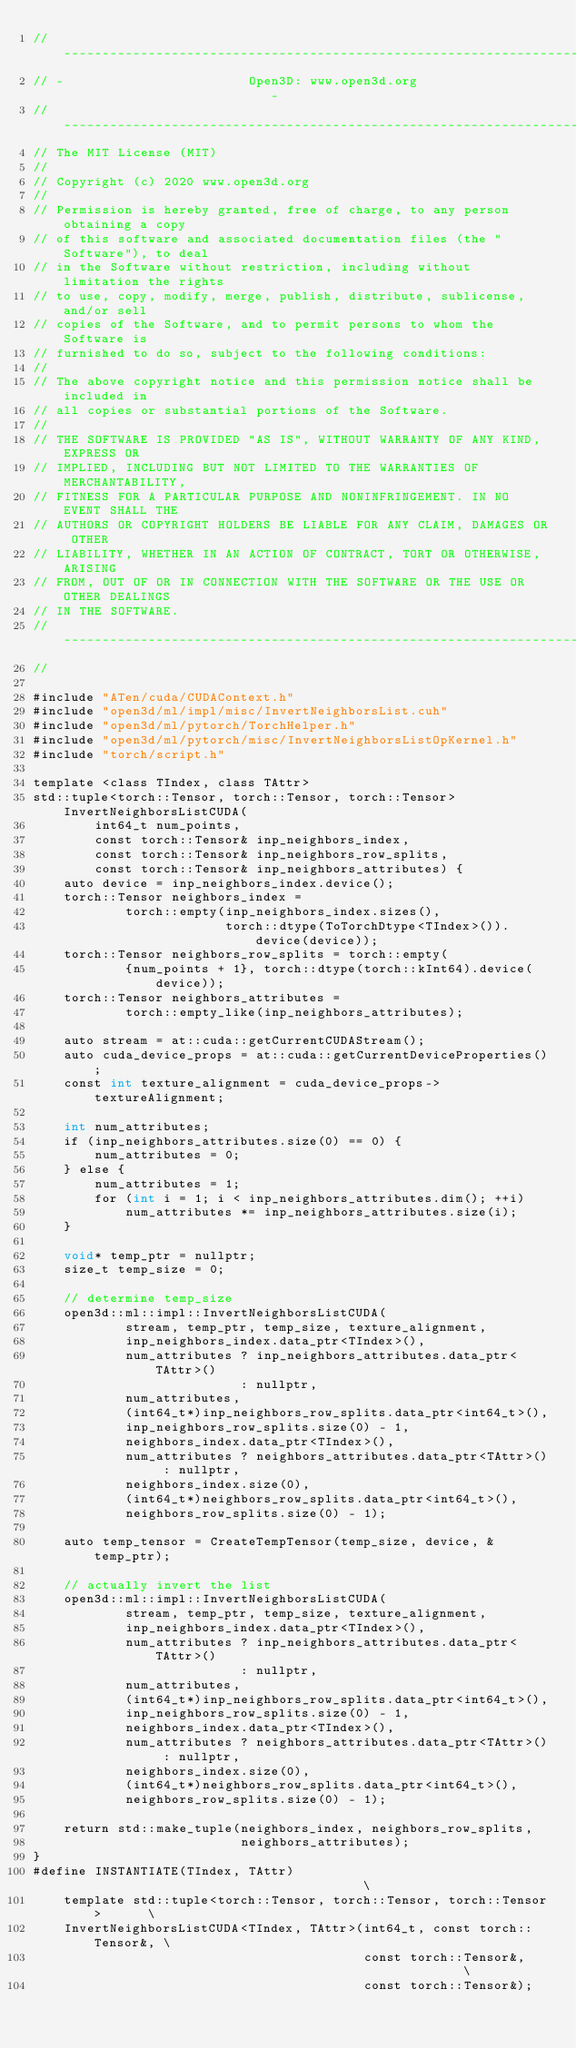Convert code to text. <code><loc_0><loc_0><loc_500><loc_500><_Cuda_>// ----------------------------------------------------------------------------
// -                        Open3D: www.open3d.org                            -
// ----------------------------------------------------------------------------
// The MIT License (MIT)
//
// Copyright (c) 2020 www.open3d.org
//
// Permission is hereby granted, free of charge, to any person obtaining a copy
// of this software and associated documentation files (the "Software"), to deal
// in the Software without restriction, including without limitation the rights
// to use, copy, modify, merge, publish, distribute, sublicense, and/or sell
// copies of the Software, and to permit persons to whom the Software is
// furnished to do so, subject to the following conditions:
//
// The above copyright notice and this permission notice shall be included in
// all copies or substantial portions of the Software.
//
// THE SOFTWARE IS PROVIDED "AS IS", WITHOUT WARRANTY OF ANY KIND, EXPRESS OR
// IMPLIED, INCLUDING BUT NOT LIMITED TO THE WARRANTIES OF MERCHANTABILITY,
// FITNESS FOR A PARTICULAR PURPOSE AND NONINFRINGEMENT. IN NO EVENT SHALL THE
// AUTHORS OR COPYRIGHT HOLDERS BE LIABLE FOR ANY CLAIM, DAMAGES OR OTHER
// LIABILITY, WHETHER IN AN ACTION OF CONTRACT, TORT OR OTHERWISE, ARISING
// FROM, OUT OF OR IN CONNECTION WITH THE SOFTWARE OR THE USE OR OTHER DEALINGS
// IN THE SOFTWARE.
// ----------------------------------------------------------------------------
//

#include "ATen/cuda/CUDAContext.h"
#include "open3d/ml/impl/misc/InvertNeighborsList.cuh"
#include "open3d/ml/pytorch/TorchHelper.h"
#include "open3d/ml/pytorch/misc/InvertNeighborsListOpKernel.h"
#include "torch/script.h"

template <class TIndex, class TAttr>
std::tuple<torch::Tensor, torch::Tensor, torch::Tensor> InvertNeighborsListCUDA(
        int64_t num_points,
        const torch::Tensor& inp_neighbors_index,
        const torch::Tensor& inp_neighbors_row_splits,
        const torch::Tensor& inp_neighbors_attributes) {
    auto device = inp_neighbors_index.device();
    torch::Tensor neighbors_index =
            torch::empty(inp_neighbors_index.sizes(),
                         torch::dtype(ToTorchDtype<TIndex>()).device(device));
    torch::Tensor neighbors_row_splits = torch::empty(
            {num_points + 1}, torch::dtype(torch::kInt64).device(device));
    torch::Tensor neighbors_attributes =
            torch::empty_like(inp_neighbors_attributes);

    auto stream = at::cuda::getCurrentCUDAStream();
    auto cuda_device_props = at::cuda::getCurrentDeviceProperties();
    const int texture_alignment = cuda_device_props->textureAlignment;

    int num_attributes;
    if (inp_neighbors_attributes.size(0) == 0) {
        num_attributes = 0;
    } else {
        num_attributes = 1;
        for (int i = 1; i < inp_neighbors_attributes.dim(); ++i)
            num_attributes *= inp_neighbors_attributes.size(i);
    }

    void* temp_ptr = nullptr;
    size_t temp_size = 0;

    // determine temp_size
    open3d::ml::impl::InvertNeighborsListCUDA(
            stream, temp_ptr, temp_size, texture_alignment,
            inp_neighbors_index.data_ptr<TIndex>(),
            num_attributes ? inp_neighbors_attributes.data_ptr<TAttr>()
                           : nullptr,
            num_attributes,
            (int64_t*)inp_neighbors_row_splits.data_ptr<int64_t>(),
            inp_neighbors_row_splits.size(0) - 1,
            neighbors_index.data_ptr<TIndex>(),
            num_attributes ? neighbors_attributes.data_ptr<TAttr>() : nullptr,
            neighbors_index.size(0),
            (int64_t*)neighbors_row_splits.data_ptr<int64_t>(),
            neighbors_row_splits.size(0) - 1);

    auto temp_tensor = CreateTempTensor(temp_size, device, &temp_ptr);

    // actually invert the list
    open3d::ml::impl::InvertNeighborsListCUDA(
            stream, temp_ptr, temp_size, texture_alignment,
            inp_neighbors_index.data_ptr<TIndex>(),
            num_attributes ? inp_neighbors_attributes.data_ptr<TAttr>()
                           : nullptr,
            num_attributes,
            (int64_t*)inp_neighbors_row_splits.data_ptr<int64_t>(),
            inp_neighbors_row_splits.size(0) - 1,
            neighbors_index.data_ptr<TIndex>(),
            num_attributes ? neighbors_attributes.data_ptr<TAttr>() : nullptr,
            neighbors_index.size(0),
            (int64_t*)neighbors_row_splits.data_ptr<int64_t>(),
            neighbors_row_splits.size(0) - 1);

    return std::make_tuple(neighbors_index, neighbors_row_splits,
                           neighbors_attributes);
}
#define INSTANTIATE(TIndex, TAttr)                                        \
    template std::tuple<torch::Tensor, torch::Tensor, torch::Tensor>      \
    InvertNeighborsListCUDA<TIndex, TAttr>(int64_t, const torch::Tensor&, \
                                           const torch::Tensor&,          \
                                           const torch::Tensor&);
</code> 